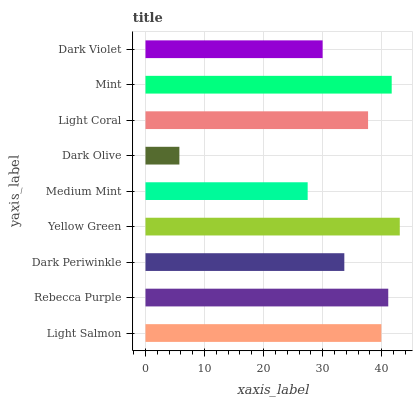Is Dark Olive the minimum?
Answer yes or no. Yes. Is Yellow Green the maximum?
Answer yes or no. Yes. Is Rebecca Purple the minimum?
Answer yes or no. No. Is Rebecca Purple the maximum?
Answer yes or no. No. Is Rebecca Purple greater than Light Salmon?
Answer yes or no. Yes. Is Light Salmon less than Rebecca Purple?
Answer yes or no. Yes. Is Light Salmon greater than Rebecca Purple?
Answer yes or no. No. Is Rebecca Purple less than Light Salmon?
Answer yes or no. No. Is Light Coral the high median?
Answer yes or no. Yes. Is Light Coral the low median?
Answer yes or no. Yes. Is Dark Olive the high median?
Answer yes or no. No. Is Medium Mint the low median?
Answer yes or no. No. 